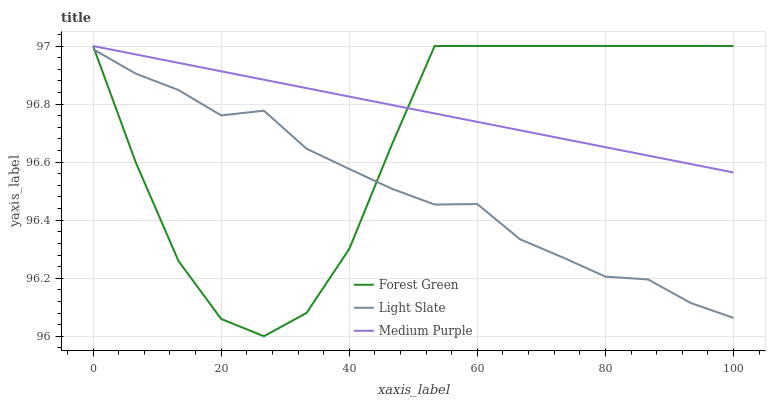Does Light Slate have the minimum area under the curve?
Answer yes or no. Yes. Does Medium Purple have the maximum area under the curve?
Answer yes or no. Yes. Does Forest Green have the minimum area under the curve?
Answer yes or no. No. Does Forest Green have the maximum area under the curve?
Answer yes or no. No. Is Medium Purple the smoothest?
Answer yes or no. Yes. Is Forest Green the roughest?
Answer yes or no. Yes. Is Forest Green the smoothest?
Answer yes or no. No. Is Medium Purple the roughest?
Answer yes or no. No. Does Forest Green have the lowest value?
Answer yes or no. Yes. Does Medium Purple have the lowest value?
Answer yes or no. No. Does Forest Green have the highest value?
Answer yes or no. Yes. Is Light Slate less than Medium Purple?
Answer yes or no. Yes. Is Medium Purple greater than Light Slate?
Answer yes or no. Yes. Does Medium Purple intersect Forest Green?
Answer yes or no. Yes. Is Medium Purple less than Forest Green?
Answer yes or no. No. Is Medium Purple greater than Forest Green?
Answer yes or no. No. Does Light Slate intersect Medium Purple?
Answer yes or no. No. 